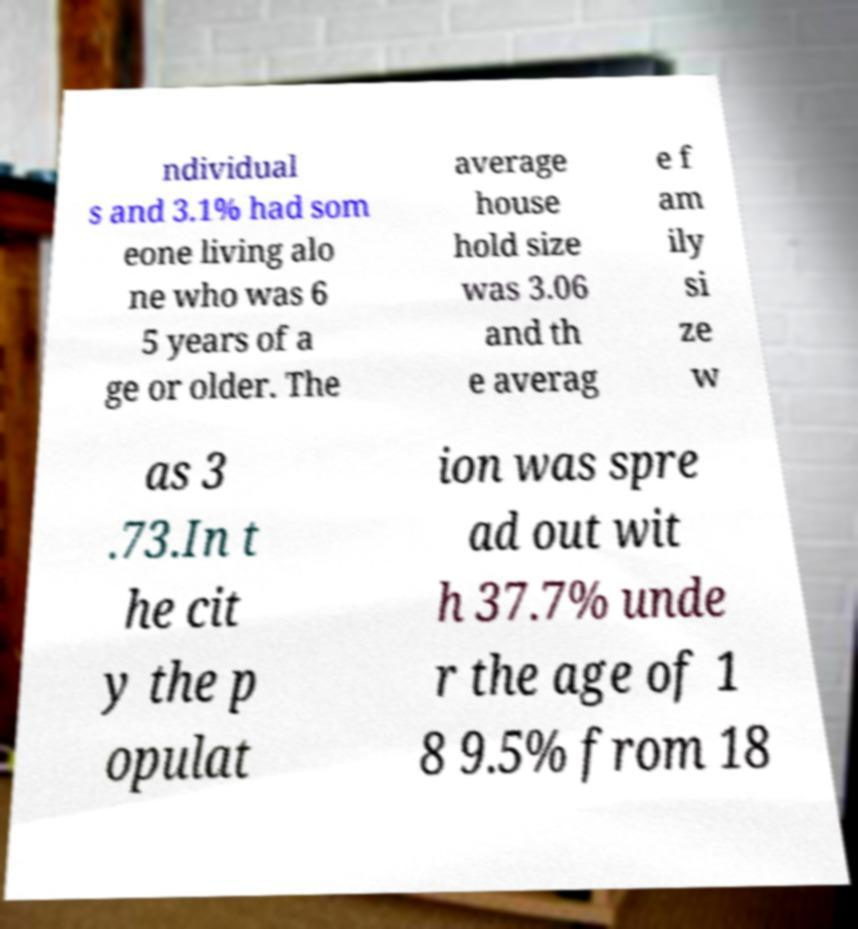I need the written content from this picture converted into text. Can you do that? ndividual s and 3.1% had som eone living alo ne who was 6 5 years of a ge or older. The average house hold size was 3.06 and th e averag e f am ily si ze w as 3 .73.In t he cit y the p opulat ion was spre ad out wit h 37.7% unde r the age of 1 8 9.5% from 18 